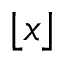<formula> <loc_0><loc_0><loc_500><loc_500>\lfloor x \rfloor</formula> 